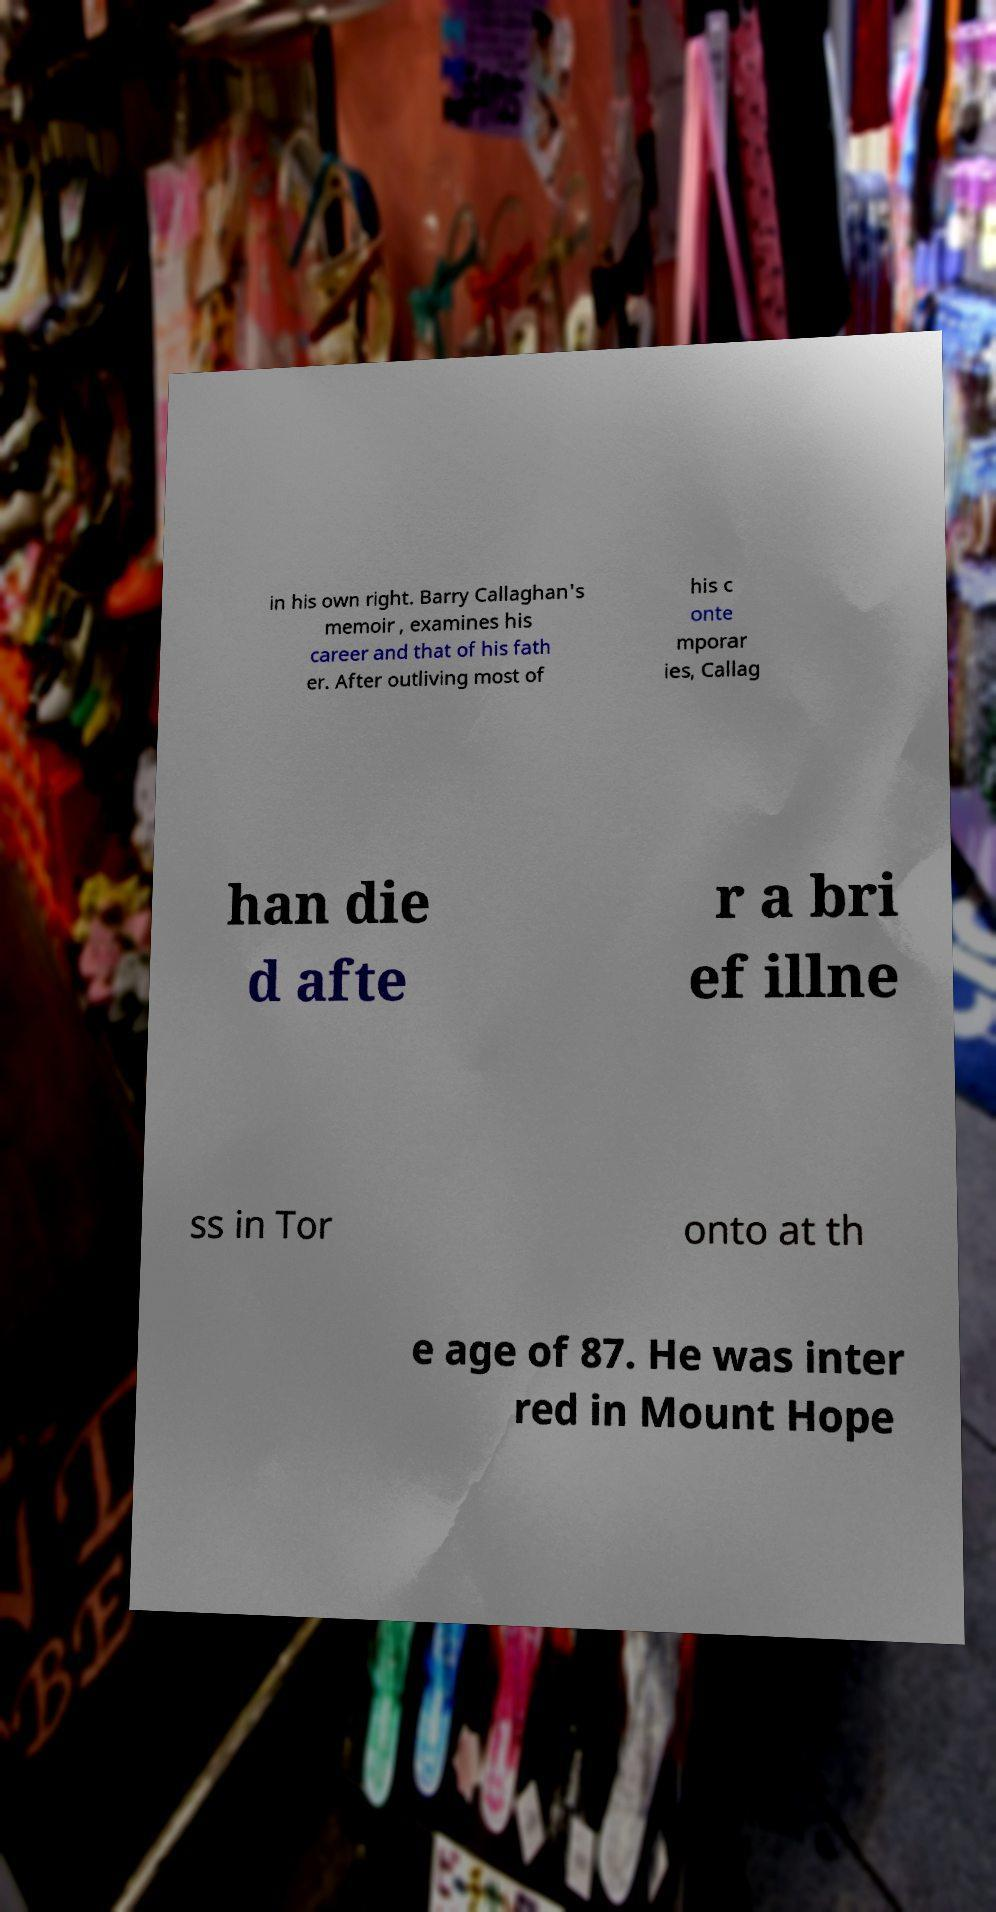Can you accurately transcribe the text from the provided image for me? in his own right. Barry Callaghan's memoir , examines his career and that of his fath er. After outliving most of his c onte mporar ies, Callag han die d afte r a bri ef illne ss in Tor onto at th e age of 87. He was inter red in Mount Hope 